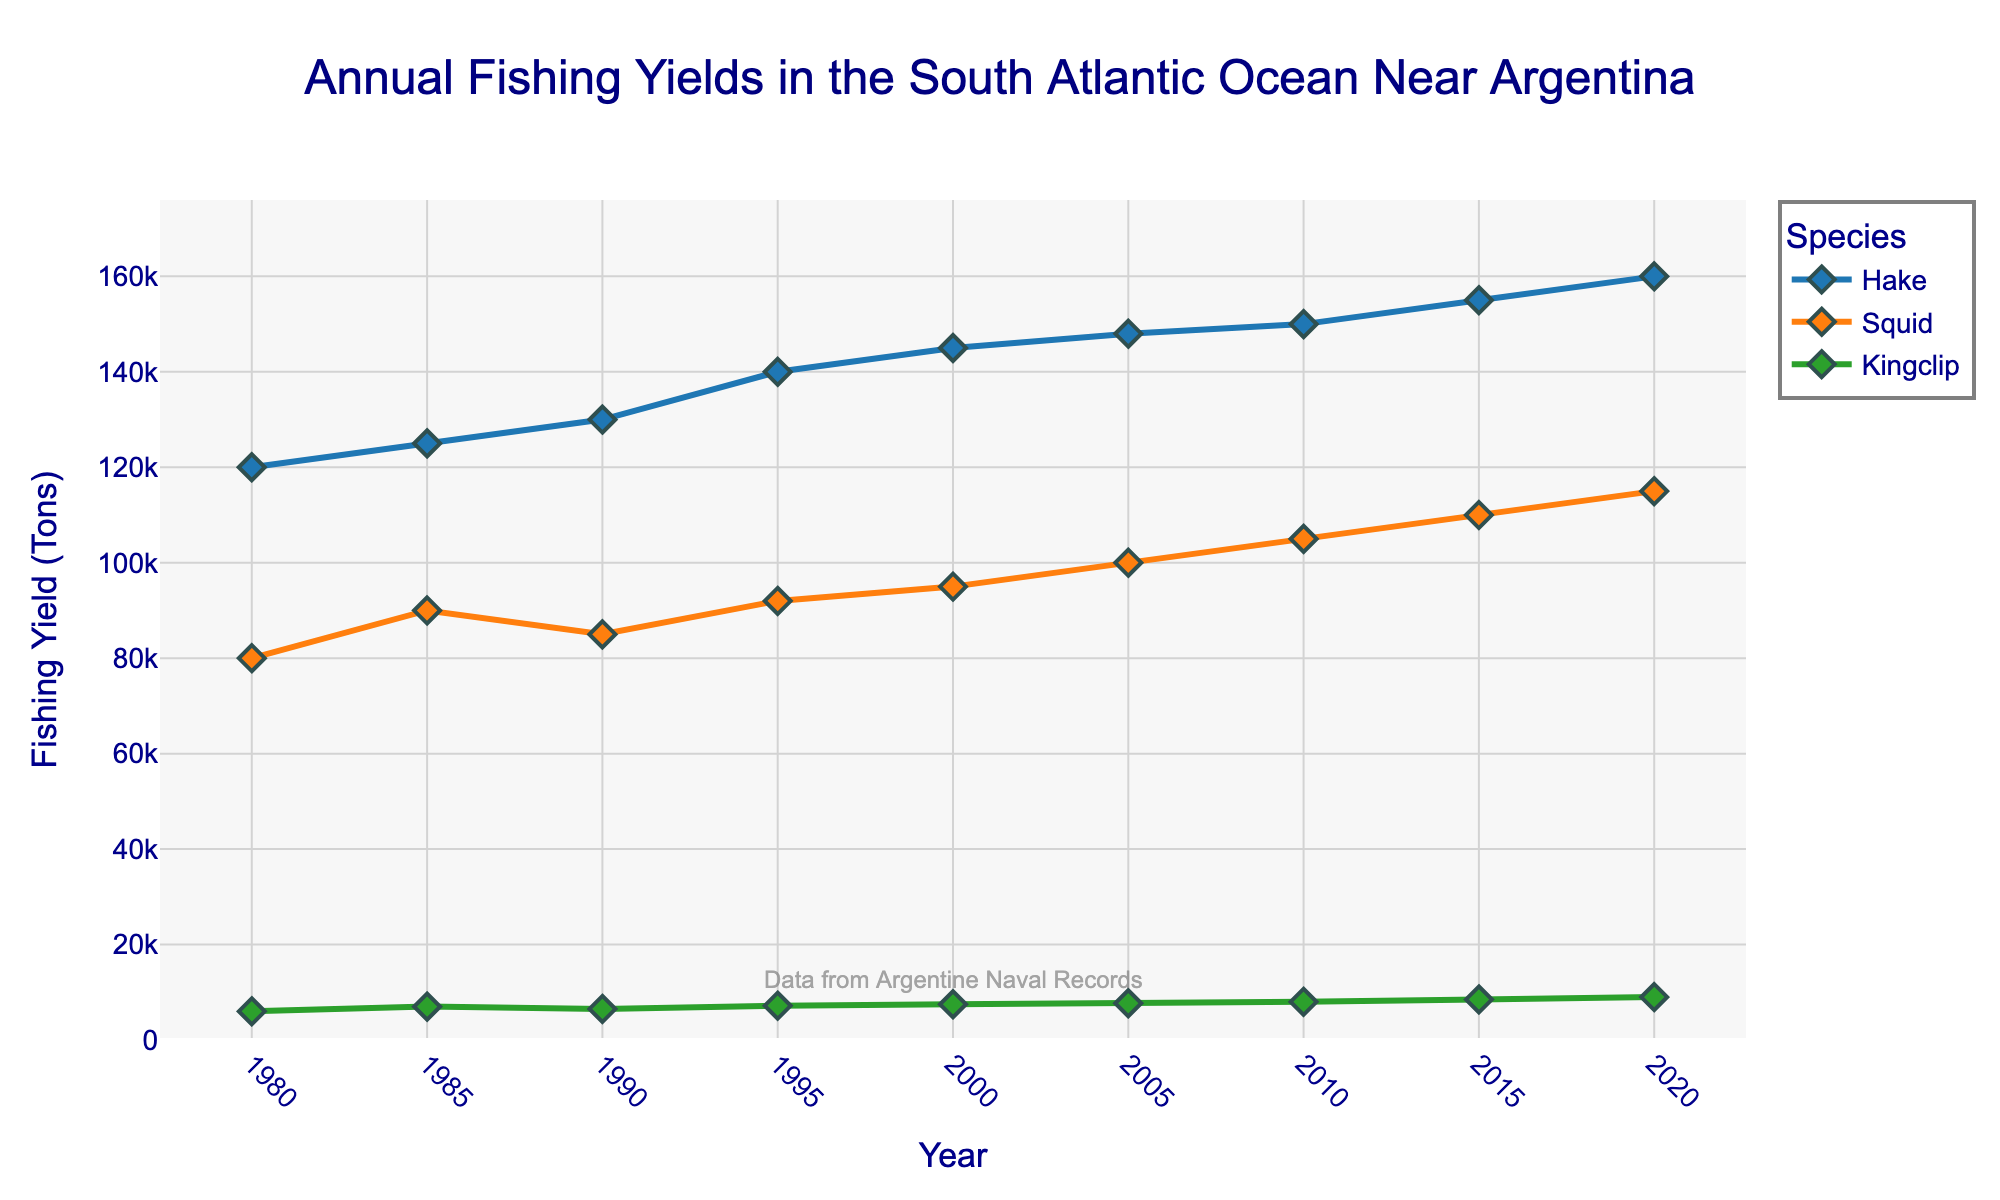What is the title of the figure? The title of the figure is displayed prominently at the top. The text reads "Annual Fishing Yields in the South Atlantic Ocean Near Argentina".
Answer: Annual Fishing Yields in the South Atlantic Ocean Near Argentina What are the three species shown in the plot? By looking at the legend on the right-hand side or examining the labels beside the lines, the three species are identified as Hake, Squid, and Kingclip.
Answer: Hake, Squid, Kingclip What is the fishing yield for Squid in the year 2000? Locate the data point on the plot where the year is 2000, follow the line for Squid, and read its value from the y-axis. The yield is 95,000 tons.
Answer: 95,000 tons Which species had the highest fishing yield in 1995? Identify the data points for each species in 1995 and compare their fishing yields. Hake has the highest yield of 140,000 tons.
Answer: Hake How has the yield for Kingclip changed from 1980 to 2020? Find the data points for Kingclip in 1980 and 2020 and compare them. In 1980, it was 6,000 tons, and in 2020, it was 9,000 tons, indicating an increase of 3,000 tons.
Answer: Increased by 3,000 tons What was the average fishing yield for Hake in the years 1980, 1985, and 1990? Add the fishing yields for Hake in these years (120,000 + 125,000 + 130,000) and divide by 3. The average yield is (120,000 + 125,000 + 130,000)/3 = 125,000 tons.
Answer: 125,000 tons Between which intervals did the yield for Squid increase the most? Calculate the yield changes for each interval: 1980-1985 (10,000), 1985-1990 (-5,000), 1990-1995 (7,000), 1995-2000 (3,000), 2000-2005 (5,000), 2005-2010 (5,000), 2010-2015 (5,000), and 2015-2020 (5,000). The largest increase is from 1980 to 1985, with an increase of 10,000 tons.
Answer: 1980 to 1985 Which species saw the least variation in fishing yields over time? Evaluate the overall change for each species from 1980 to 2020 and compare them: Hake (120,000 to 160,000), Squid (80,000 to 115,000), Kingclip (6,000 to 9,000). Kingclip has the smallest overall change.
Answer: Kingclip What was the total fishing yield for all species combined in 2020? Sum the fishing yields for the three species in 2020: Hake (160,000), Squid (115,000), and Kingclip (9,000). The total yield is 160,000 + 115,000 + 9,000 = 284,000 tons.
Answer: 284,000 tons 